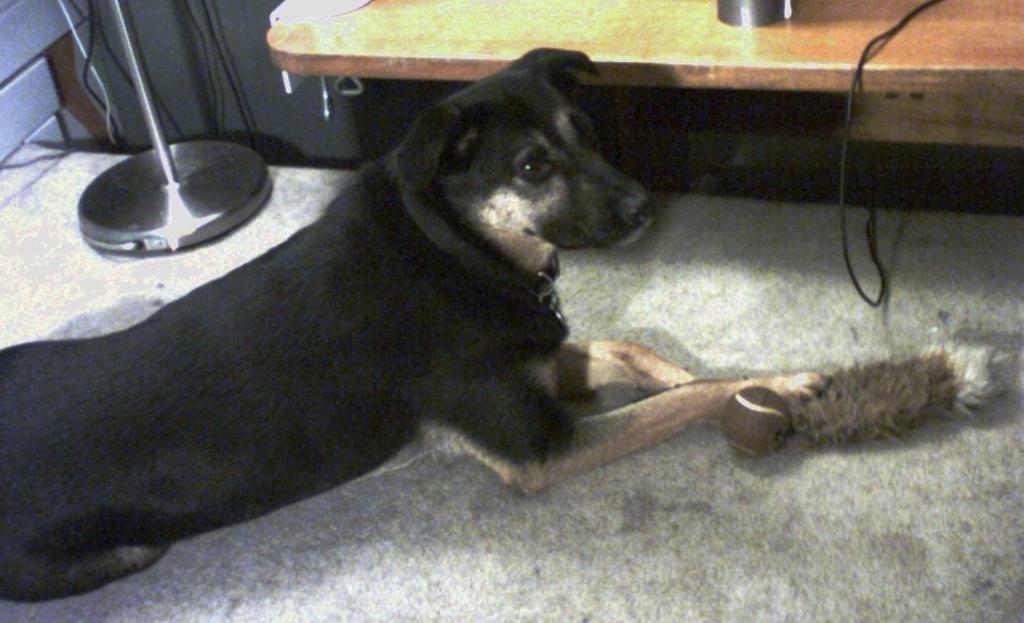Please provide a concise description of this image. In this image I can see a dog on the floor and some objects. In the background I can see stand, wires and a desk. This image is taken may be in a room. 